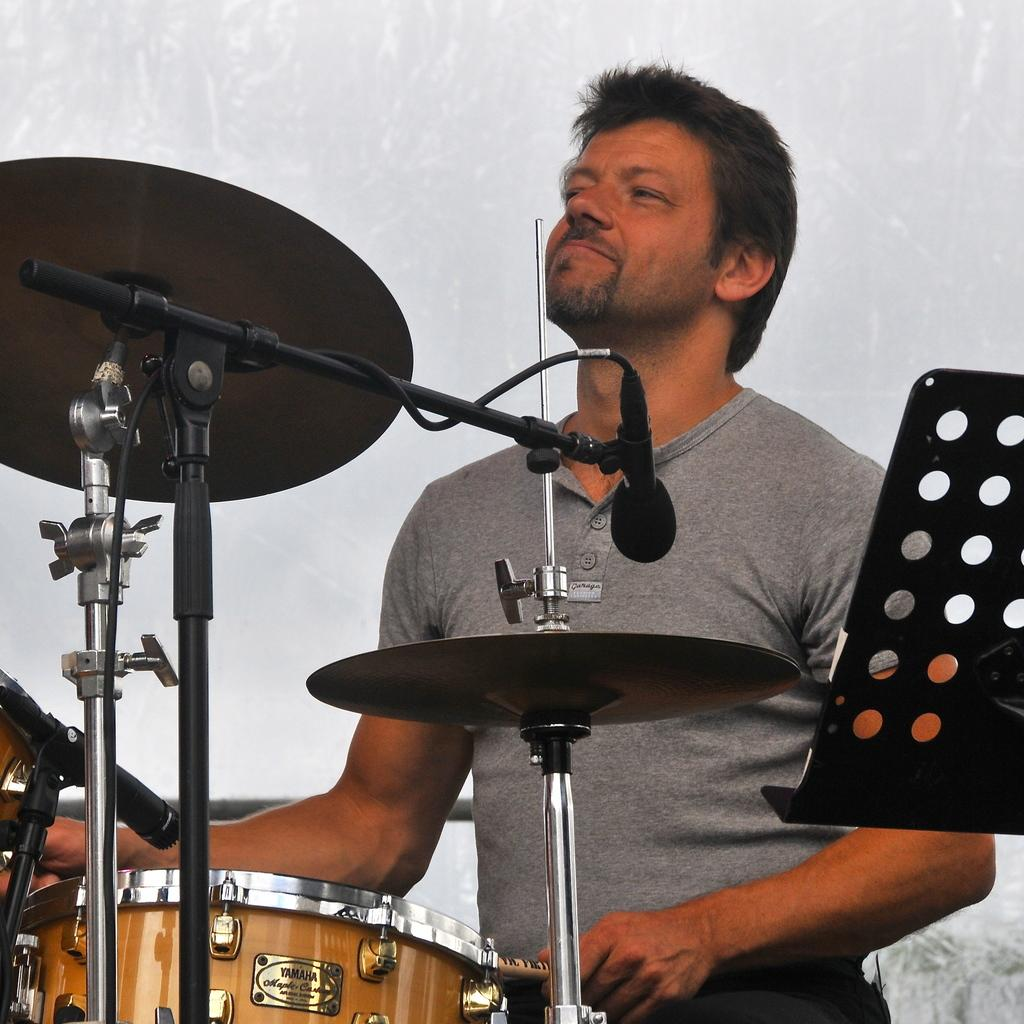What is the main subject of the image? There is a person in the image. What is the person wearing? The person is wearing a dress. What activity is the person engaged in? The person is playing a drum set. How would you describe the background of the image? The background of the image is ash colored. What type of honey can be seen dripping from the drum set in the image? There is no honey present in the image, and therefore no such activity can be observed. 